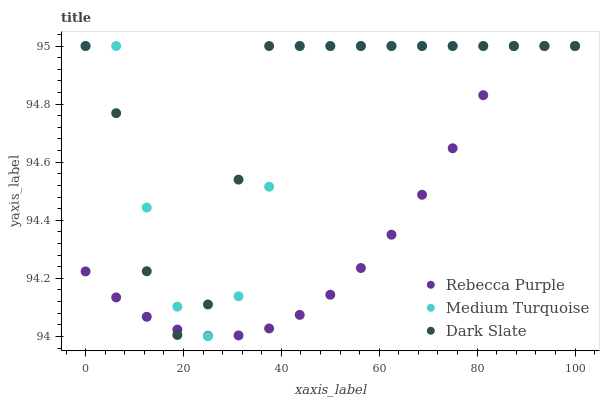Does Rebecca Purple have the minimum area under the curve?
Answer yes or no. Yes. Does Dark Slate have the maximum area under the curve?
Answer yes or no. Yes. Does Medium Turquoise have the minimum area under the curve?
Answer yes or no. No. Does Medium Turquoise have the maximum area under the curve?
Answer yes or no. No. Is Rebecca Purple the smoothest?
Answer yes or no. Yes. Is Medium Turquoise the roughest?
Answer yes or no. Yes. Is Medium Turquoise the smoothest?
Answer yes or no. No. Is Rebecca Purple the roughest?
Answer yes or no. No. Does Medium Turquoise have the lowest value?
Answer yes or no. Yes. Does Rebecca Purple have the lowest value?
Answer yes or no. No. Does Medium Turquoise have the highest value?
Answer yes or no. Yes. Does Rebecca Purple intersect Dark Slate?
Answer yes or no. Yes. Is Rebecca Purple less than Dark Slate?
Answer yes or no. No. Is Rebecca Purple greater than Dark Slate?
Answer yes or no. No. 